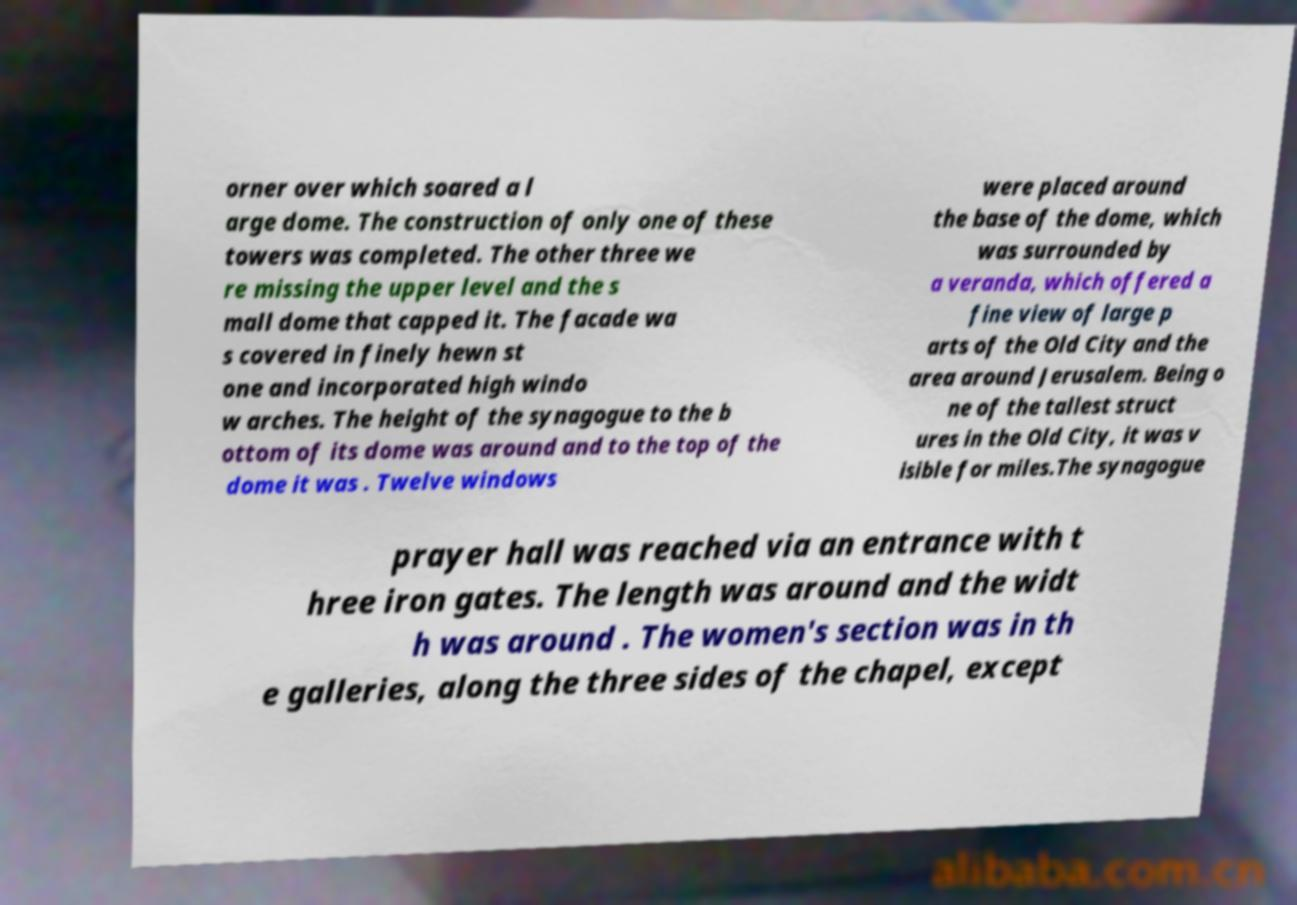Please read and relay the text visible in this image. What does it say? orner over which soared a l arge dome. The construction of only one of these towers was completed. The other three we re missing the upper level and the s mall dome that capped it. The facade wa s covered in finely hewn st one and incorporated high windo w arches. The height of the synagogue to the b ottom of its dome was around and to the top of the dome it was . Twelve windows were placed around the base of the dome, which was surrounded by a veranda, which offered a fine view of large p arts of the Old City and the area around Jerusalem. Being o ne of the tallest struct ures in the Old City, it was v isible for miles.The synagogue prayer hall was reached via an entrance with t hree iron gates. The length was around and the widt h was around . The women's section was in th e galleries, along the three sides of the chapel, except 